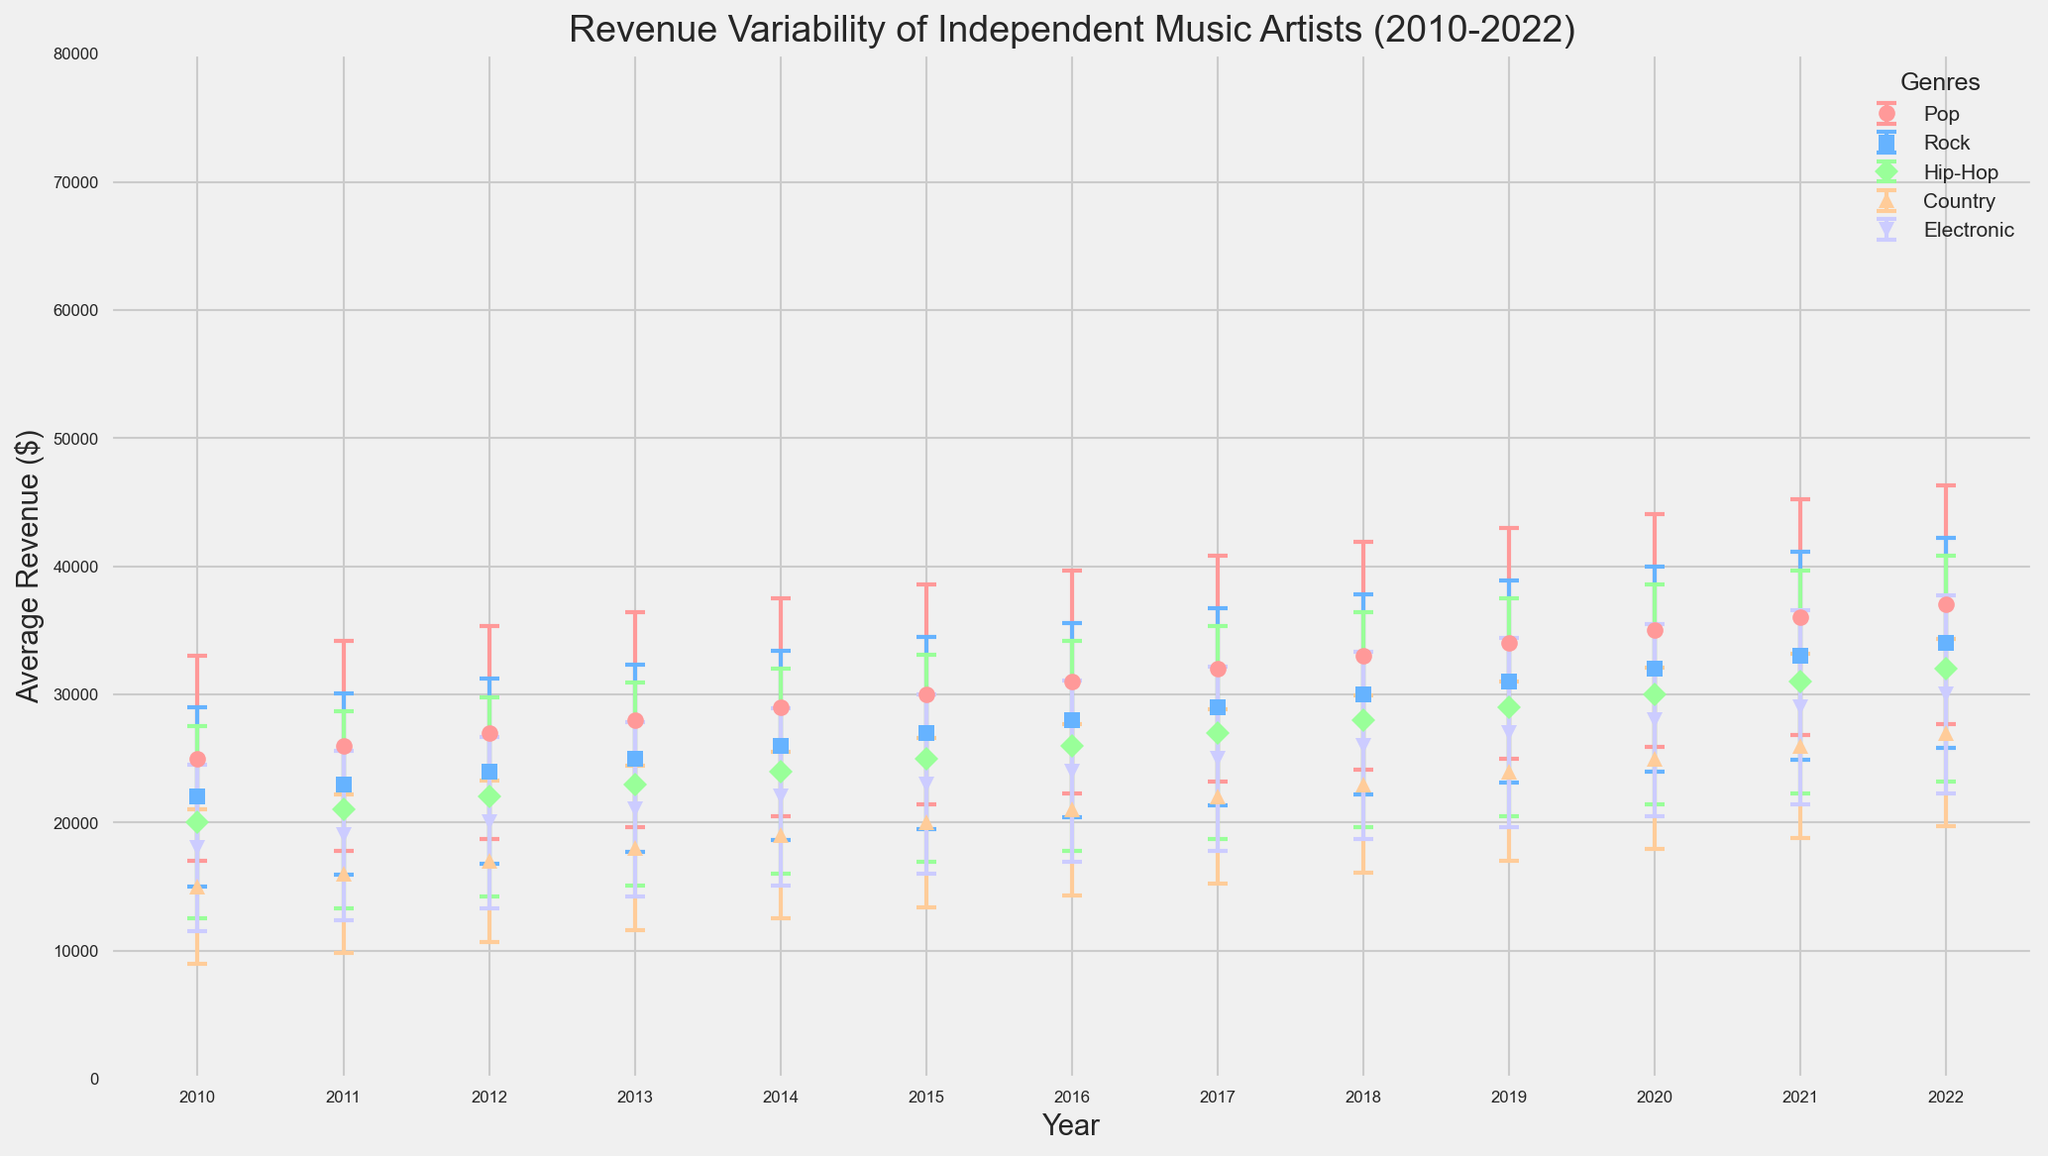How does the average revenue for Pop artists in 2022 compare to Rock artists in 2022? The average revenue for Pop artists in 2022 is $37,000, while for Rock artists it is $34,000. Comparing these, Pop artists have a higher average revenue by $3,000.
Answer: Pop artists have a higher average revenue by $3,000 Between which consecutive years did Hip-Hop artists see the largest increase in average revenue? By observing the graph, the largest increase in average revenue for Hip-Hop artists occurred between 2014 ($24,000) and 2015 ($25,000), an increase of $4,000.
Answer: Between 2014 and 2015 Which genre had the highest average revenue in 2020? By examining the figure, Pop artists had the highest average revenue in 2020 at $35,000.
Answer: Pop What is the general trend for Electronic music average revenue from 2010 to 2022? Over the period from 2010 to 2022, average revenue for Electronic music steadily increased from $18,000 in 2010 to $30,000 in 2022.
Answer: Steadily increased In 2015, which genre had the smallest standard deviation in revenue? The graph shows that in 2015, Country artists had the smallest standard deviation in revenue with $6,600.
Answer: Country Which genre showed the most consistent growth in average revenue from 2010 to 2022? To evaluate consistency, we can look for the genre with the most steady upward slope. Pop consistently increases from $25,000 in 2010 to $37,000 in 2022, representing a consistent growth trend.
Answer: Pop How much did the average revenue for Country music change from 2010 to 2015? The average revenue for Country music increased from $15,000 in 2010 to $20,000 in 2015, a difference of $5,000.
Answer: Increased by $5,000 Which year had the highest standard deviation in revenue for Pop artists, and what was the value? By identifying the year with visually the largest error bar for Pop, 2022 had the highest standard deviation, with a value of $9,300.
Answer: 2022, $9,300 